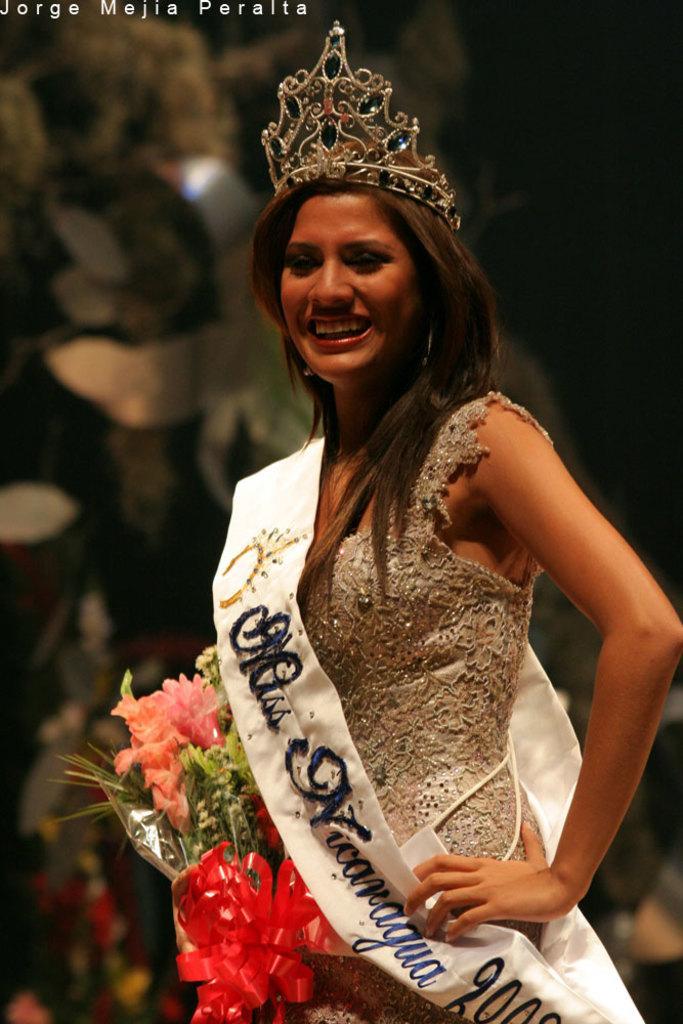Describe this image in one or two sentences. In this image we can see a woman holding a bouquet and she is smiling. There is a blur background. At the top of the image we can see something is written on it. 